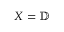<formula> <loc_0><loc_0><loc_500><loc_500>X = \mathbb { D }</formula> 